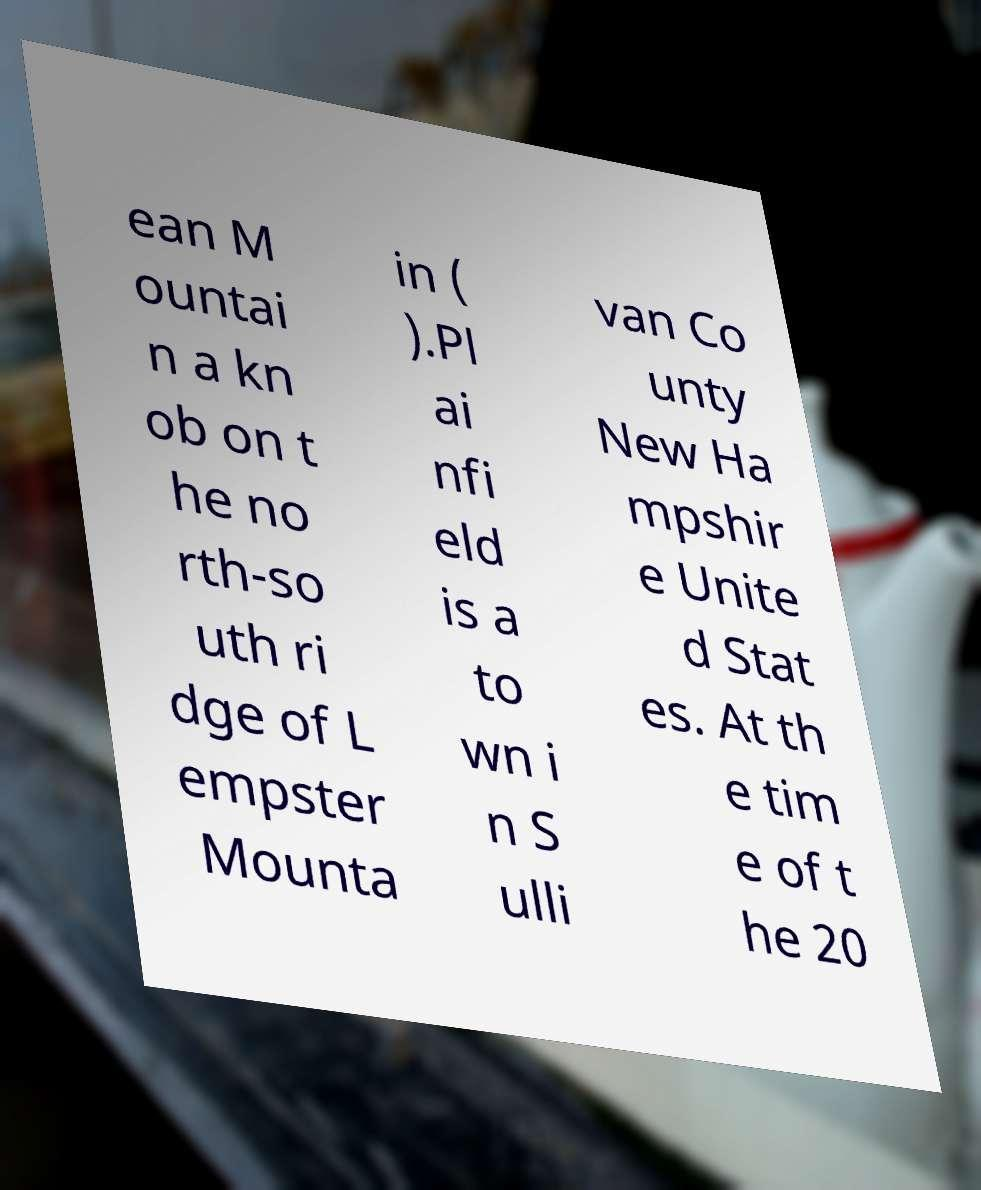Can you read and provide the text displayed in the image?This photo seems to have some interesting text. Can you extract and type it out for me? ean M ountai n a kn ob on t he no rth-so uth ri dge of L empster Mounta in ( ).Pl ai nfi eld is a to wn i n S ulli van Co unty New Ha mpshir e Unite d Stat es. At th e tim e of t he 20 